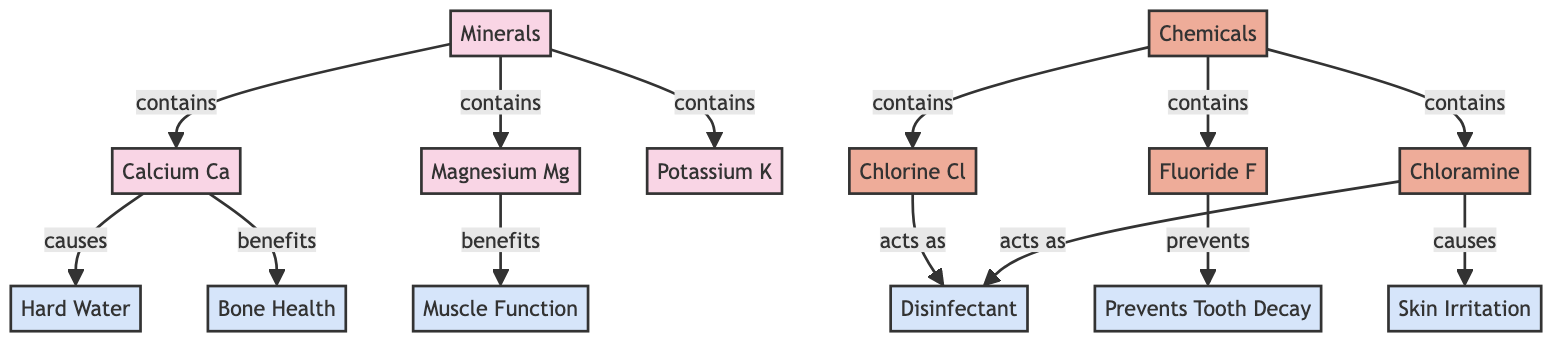What are the minerals present in local tap water? The diagram indicates that the minerals present in local tap water include calcium, magnesium, and potassium. These are the specific nodes connected to the minerals group in the diagram.
Answer: Calcium, Magnesium, Potassium How many types of chemicals are listed in the diagram? According to the diagram, there are three types of chemicals mentioned: chlorine, fluoride, and chloramine. Each of these is a separate node under the chemicals category.
Answer: Three What health impact is associated with calcium? The diagram shows that calcium benefits bone health. It is represented as a connection from the calcium node to the bone health effect node, indicating its positive impact.
Answer: Bone Health What effect does fluoride have? Fluoride prevents tooth decay, as indicated in the diagram by the connection from the fluoride node to the prevents tooth decay effect node.
Answer: Prevents Tooth Decay Which chemical acts as a disinfectant? The diagram highlights that both chlorine and chloramine act as disinfectants, as shown by the connections from each of these nodes to the disinfectant effect node.
Answer: Chlorine, Chloramine What is the relationship between chloramine and skin irritation? The diagram indicates that chloramine causes skin irritation. This is shown by the direct connection between the chloramine node and the skin irritation effect node.
Answer: Skin Irritation How does magnesium benefit health? The diagram illustrates that magnesium benefits muscle function. This connection is clearly represented in the diagram, linking the magnesium node to the muscle function effect node.
Answer: Muscle Function What does hard water result from? Hard water is caused by the presence of calcium in tap water, which is depicted in the diagram as a direct link from calcium to hard water.
Answer: Calcium Which mineral is involved in bone health? The diagram specifically shows that calcium plays a role in bone health, as indicated by the direct connection from the calcium node to the bone health effect node.
Answer: Calcium 